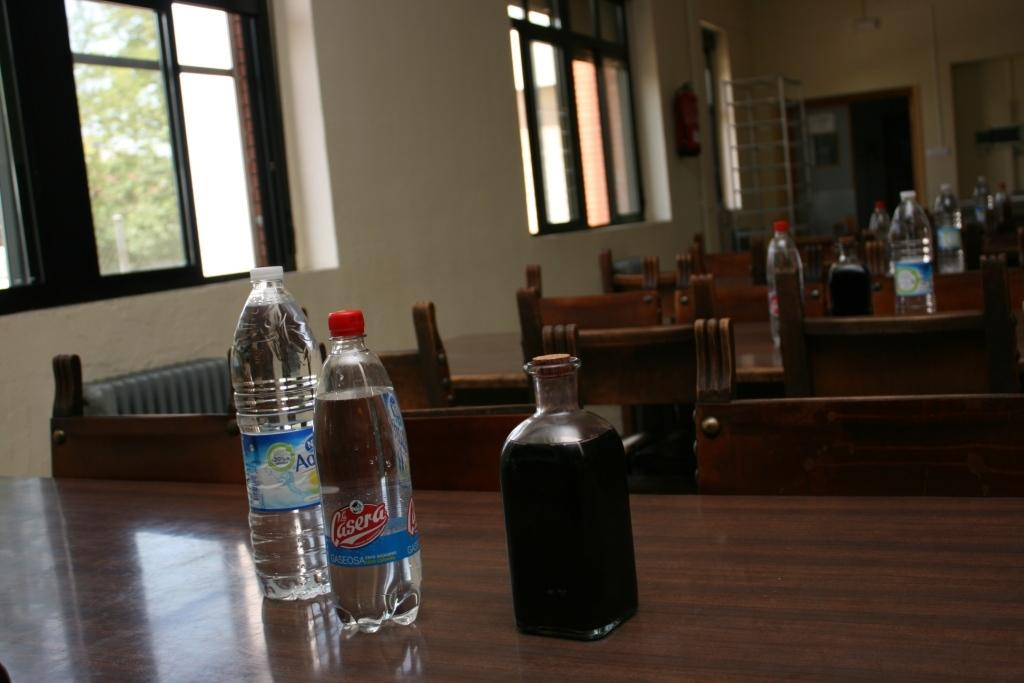<image>
Give a short and clear explanation of the subsequent image. The drink with the red bottle cap is La Casera. 